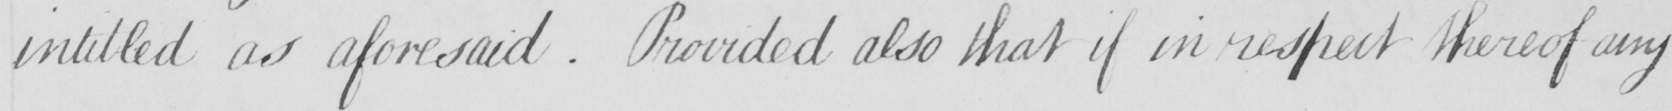What does this handwritten line say? intitled as aforesaid . Provided also that if in respect thereof any 